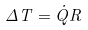<formula> <loc_0><loc_0><loc_500><loc_500>\Delta T = \dot { Q } R</formula> 